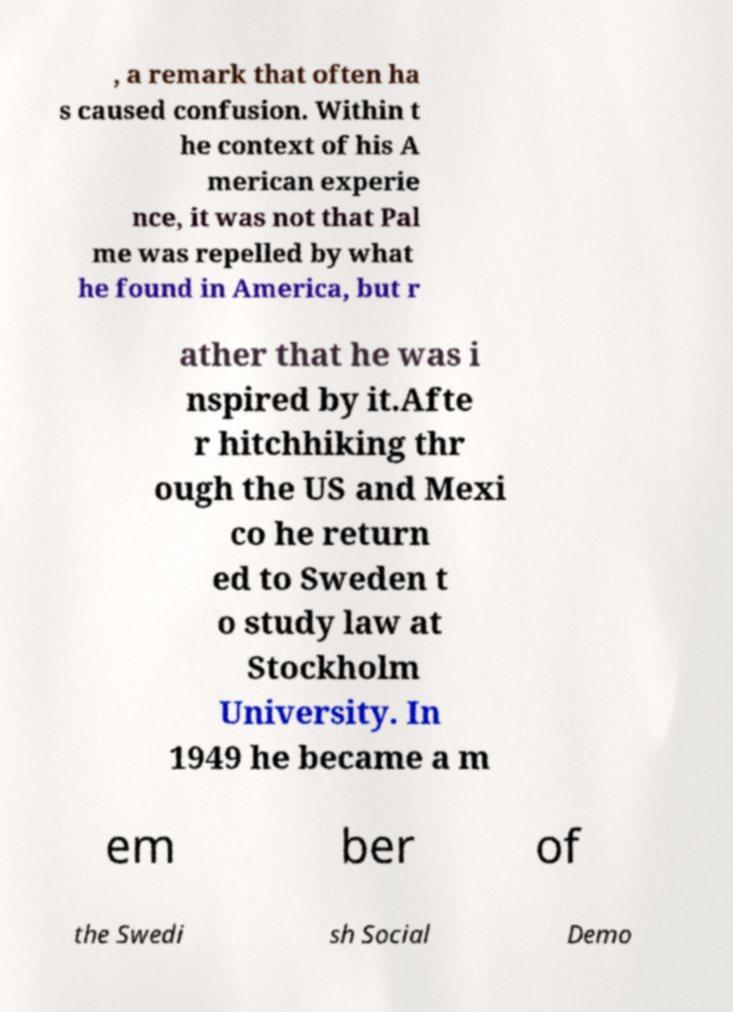Please read and relay the text visible in this image. What does it say? , a remark that often ha s caused confusion. Within t he context of his A merican experie nce, it was not that Pal me was repelled by what he found in America, but r ather that he was i nspired by it.Afte r hitchhiking thr ough the US and Mexi co he return ed to Sweden t o study law at Stockholm University. In 1949 he became a m em ber of the Swedi sh Social Demo 